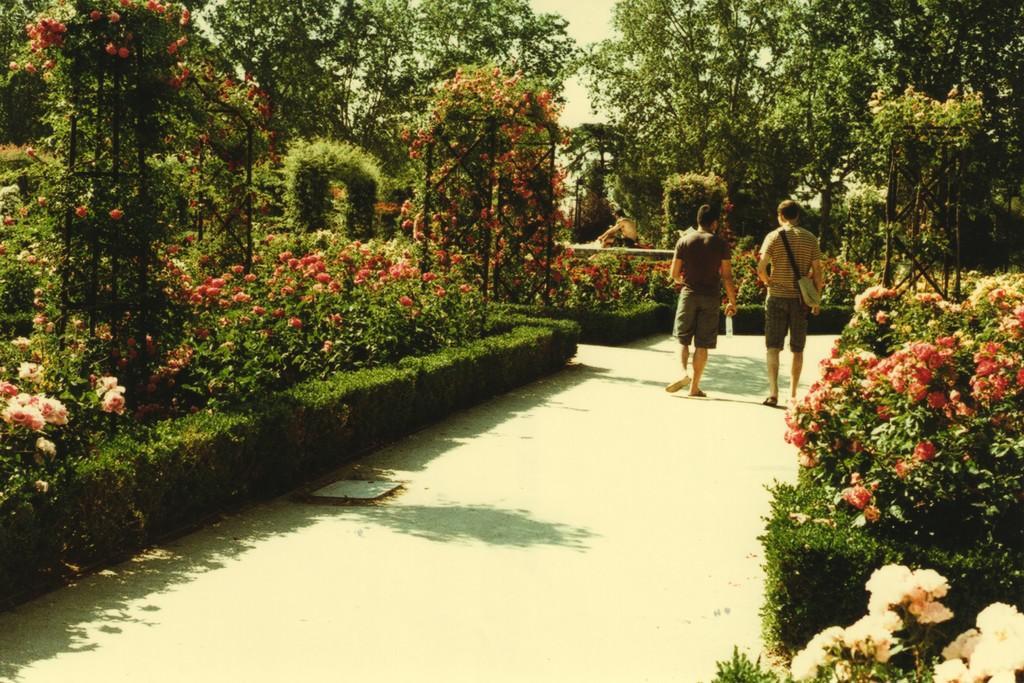Please provide a concise description of this image. There are two men walking on the road. On either side of them, there are plants and shrubs. There are trees in the background. This picture might be clicked in the garden. 